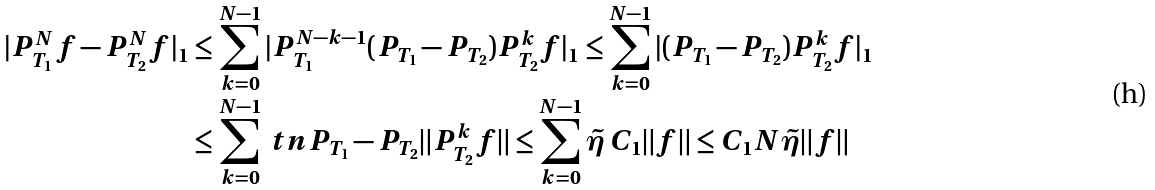Convert formula to latex. <formula><loc_0><loc_0><loc_500><loc_500>| P _ { T _ { 1 } } ^ { N } f - P _ { T _ { 2 } } ^ { N } f | _ { 1 } & \leq \sum _ { k = 0 } ^ { N - 1 } | P _ { T _ { 1 } } ^ { N - k - 1 } ( P _ { T _ { 1 } } - P _ { T _ { 2 } } ) P _ { T _ { 2 } } ^ { k } f | _ { 1 } \leq \sum _ { k = 0 } ^ { N - 1 } | ( P _ { T _ { 1 } } - P _ { T _ { 2 } } ) P _ { T _ { 2 } } ^ { k } f | _ { 1 } \\ & \leq \sum _ { k = 0 } ^ { N - 1 } \ t n { P _ { T _ { 1 } } - P _ { T _ { 2 } } } \| P _ { T _ { 2 } } ^ { k } f \| \leq \sum _ { k = 0 } ^ { N - 1 } \tilde { \eta } \, C _ { 1 } \| f \| \leq C _ { 1 } N \tilde { \eta } \| f \|</formula> 